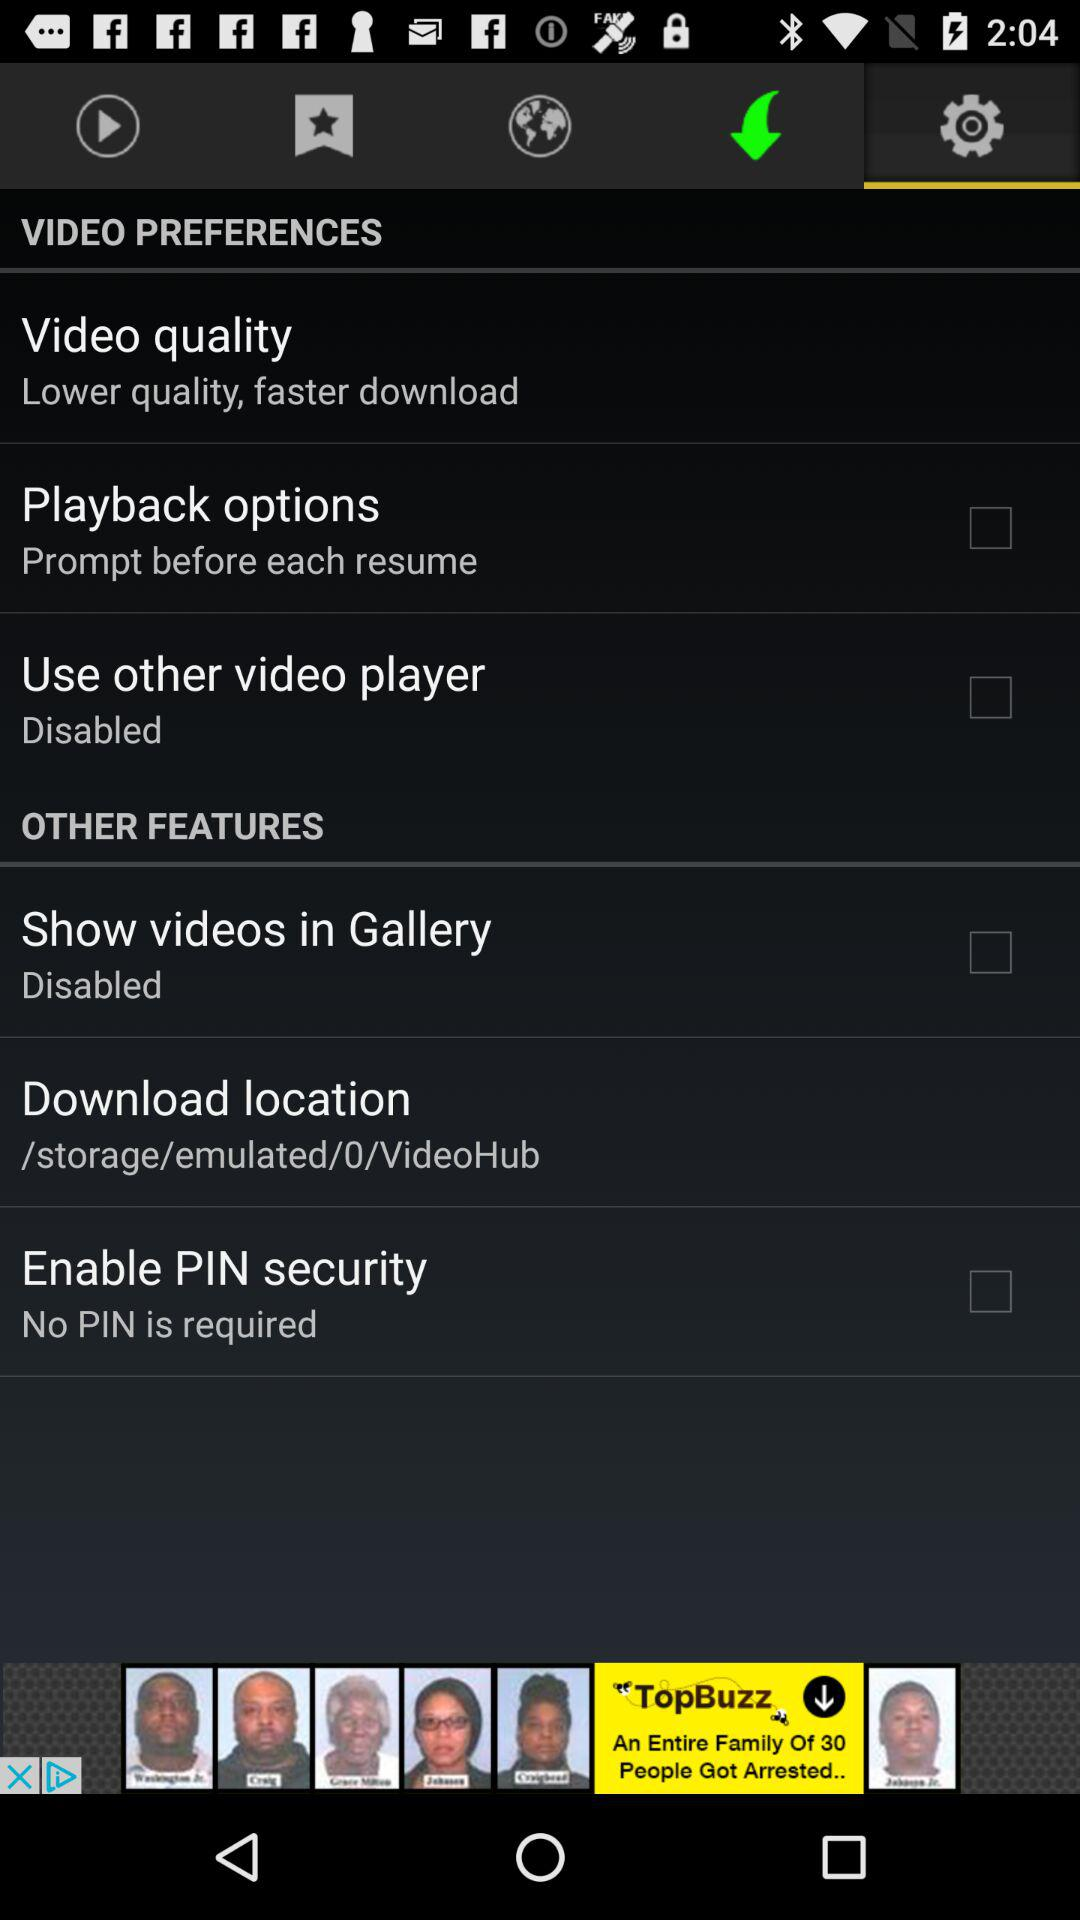How many of the items are disabled?
Answer the question using a single word or phrase. 2 